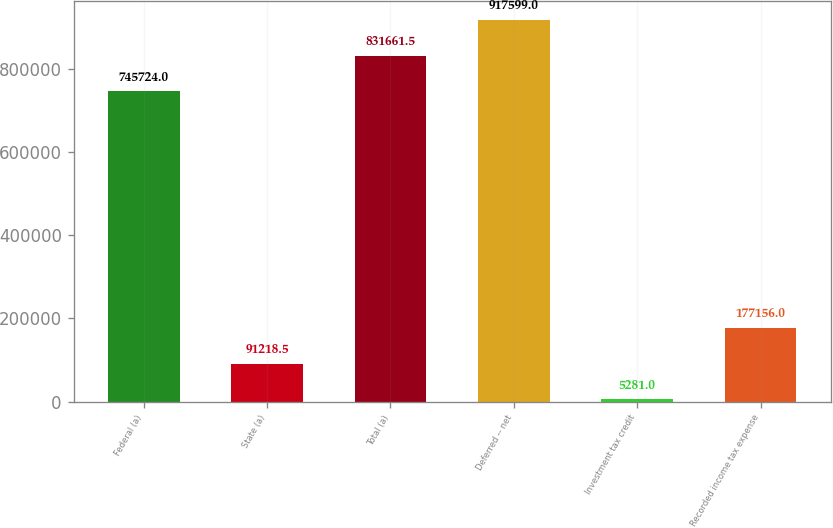Convert chart. <chart><loc_0><loc_0><loc_500><loc_500><bar_chart><fcel>Federal (a)<fcel>State (a)<fcel>Total (a)<fcel>Deferred -- net<fcel>Investment tax credit<fcel>Recorded income tax expense<nl><fcel>745724<fcel>91218.5<fcel>831662<fcel>917599<fcel>5281<fcel>177156<nl></chart> 